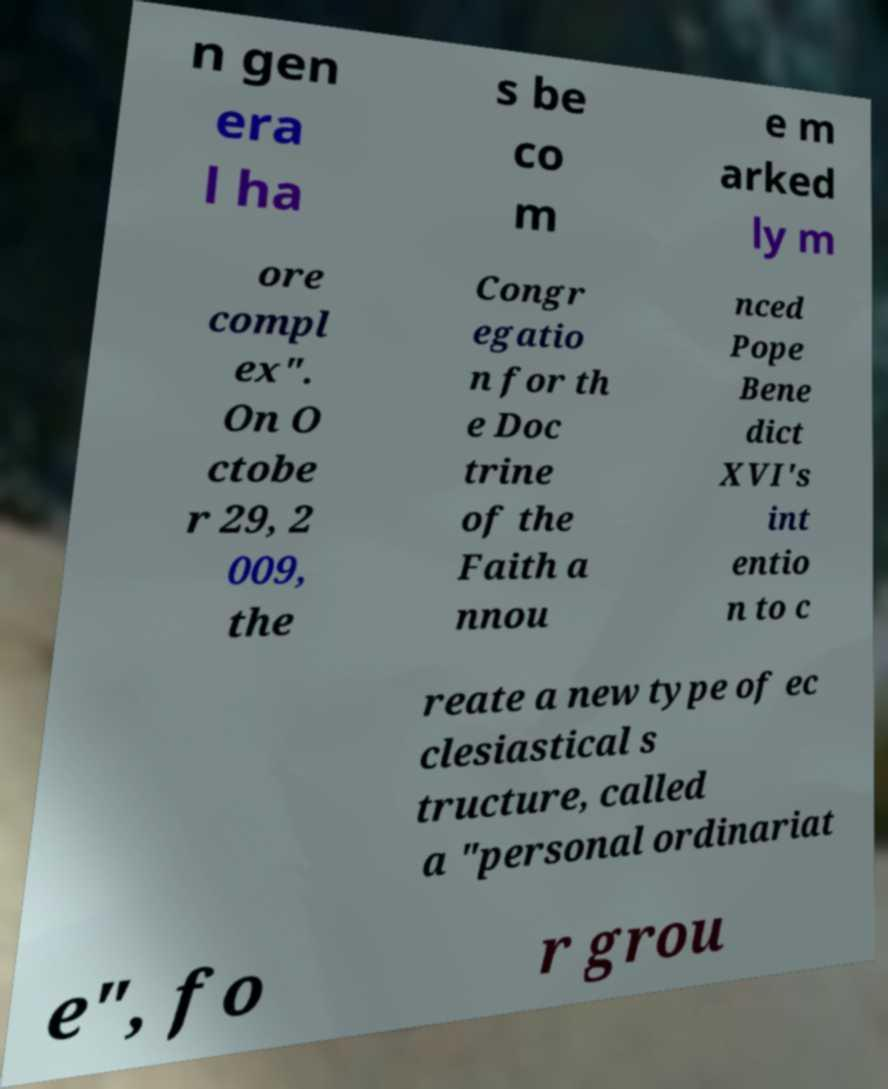Can you accurately transcribe the text from the provided image for me? n gen era l ha s be co m e m arked ly m ore compl ex". On O ctobe r 29, 2 009, the Congr egatio n for th e Doc trine of the Faith a nnou nced Pope Bene dict XVI's int entio n to c reate a new type of ec clesiastical s tructure, called a "personal ordinariat e", fo r grou 